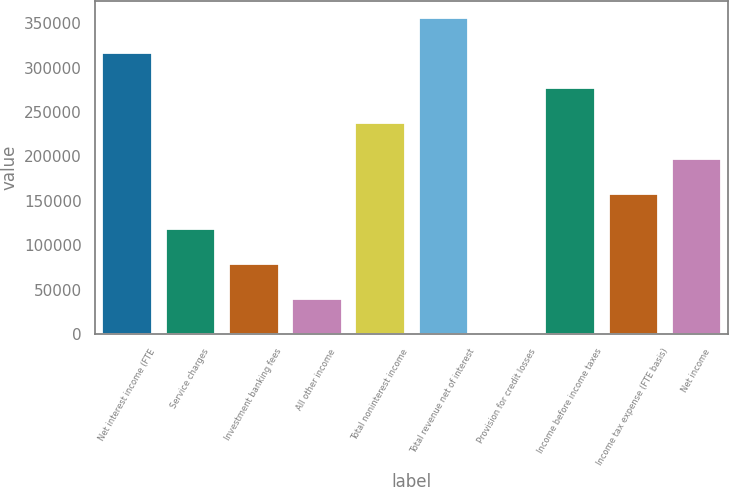<chart> <loc_0><loc_0><loc_500><loc_500><bar_chart><fcel>Net interest income (FTE<fcel>Service charges<fcel>Investment banking fees<fcel>All other income<fcel>Total noninterest income<fcel>Total revenue net of interest<fcel>Provision for credit losses<fcel>Income before income taxes<fcel>Income tax expense (FTE basis)<fcel>Net income<nl><fcel>317541<fcel>119630<fcel>80047.4<fcel>40465.2<fcel>238376<fcel>357123<fcel>883<fcel>277958<fcel>159212<fcel>198794<nl></chart> 